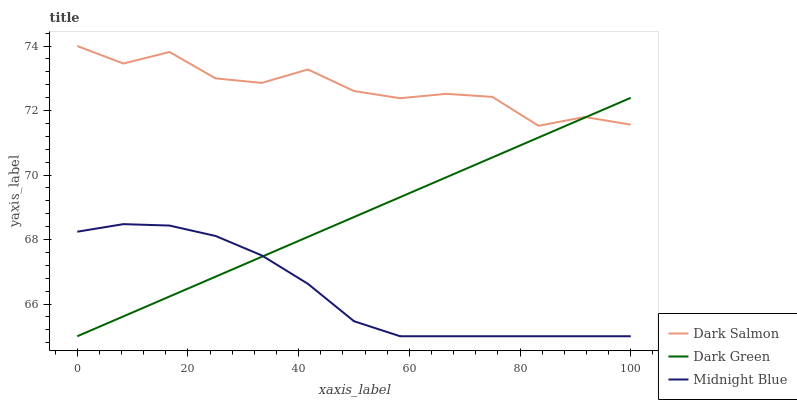Does Midnight Blue have the minimum area under the curve?
Answer yes or no. Yes. Does Dark Salmon have the maximum area under the curve?
Answer yes or no. Yes. Does Dark Green have the minimum area under the curve?
Answer yes or no. No. Does Dark Green have the maximum area under the curve?
Answer yes or no. No. Is Dark Green the smoothest?
Answer yes or no. Yes. Is Dark Salmon the roughest?
Answer yes or no. Yes. Is Dark Salmon the smoothest?
Answer yes or no. No. Is Dark Green the roughest?
Answer yes or no. No. Does Dark Salmon have the lowest value?
Answer yes or no. No. Does Dark Salmon have the highest value?
Answer yes or no. Yes. Does Dark Green have the highest value?
Answer yes or no. No. Is Midnight Blue less than Dark Salmon?
Answer yes or no. Yes. Is Dark Salmon greater than Midnight Blue?
Answer yes or no. Yes. Does Dark Green intersect Dark Salmon?
Answer yes or no. Yes. Is Dark Green less than Dark Salmon?
Answer yes or no. No. Is Dark Green greater than Dark Salmon?
Answer yes or no. No. Does Midnight Blue intersect Dark Salmon?
Answer yes or no. No. 